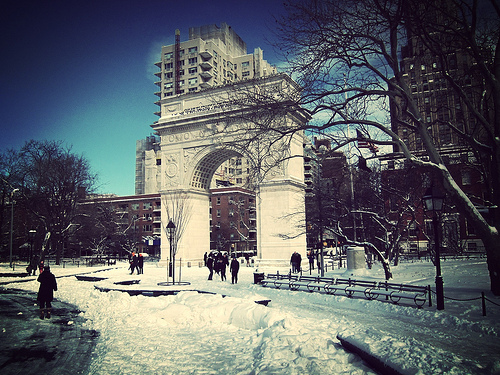<image>
Is the archway in front of the building? Yes. The archway is positioned in front of the building, appearing closer to the camera viewpoint. 